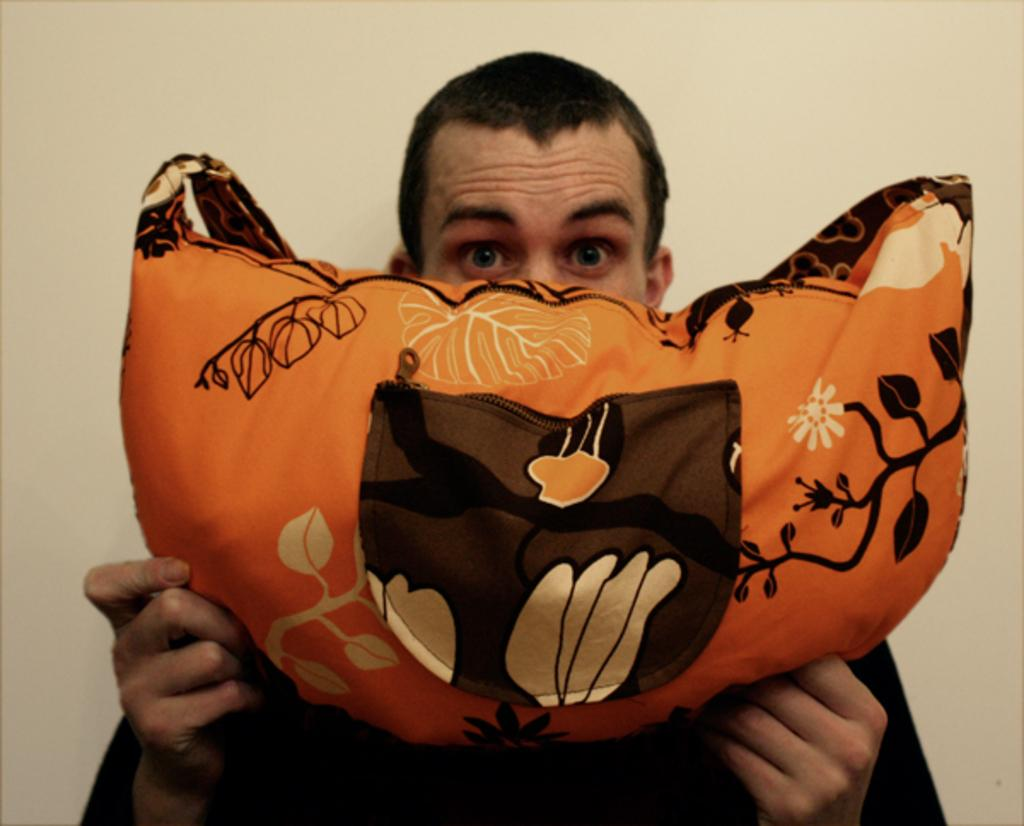Who is present in the image? There is a man in the image. What is the man holding in the image? The man is holding a bag. What can be seen in the background of the image? There is a wall in the background of the image. Where are the chickens located in the image? There are no chickens present in the image. 